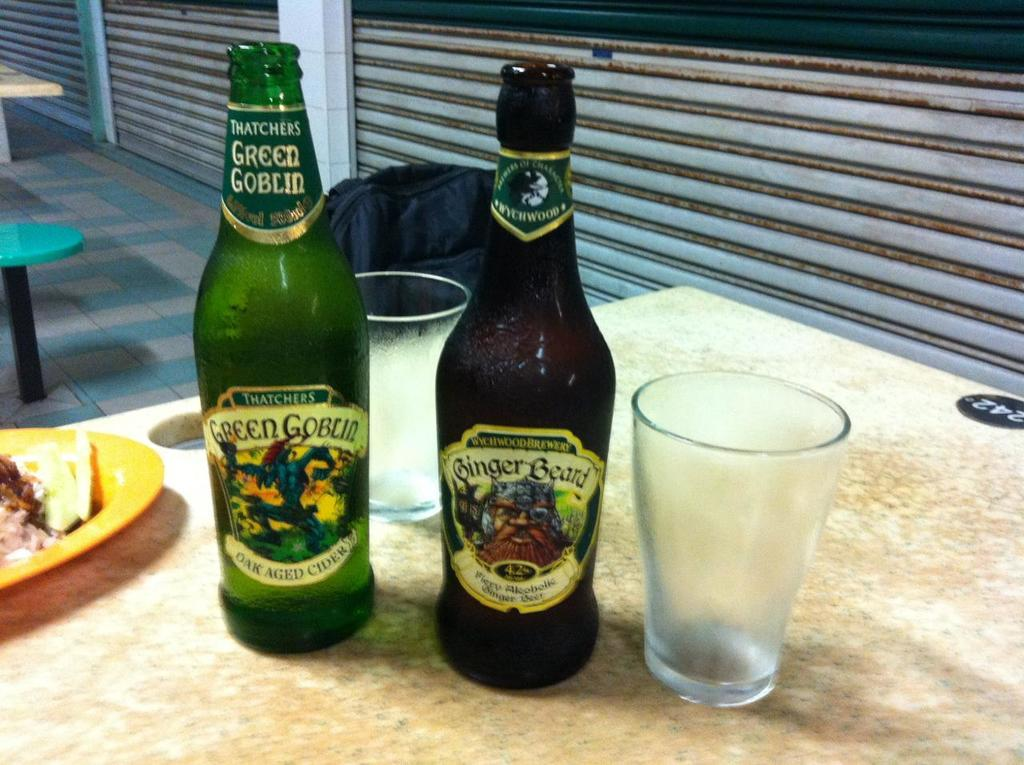<image>
Render a clear and concise summary of the photo. A bottle of Green Goblin is on a counter next to another bottle of beer. 